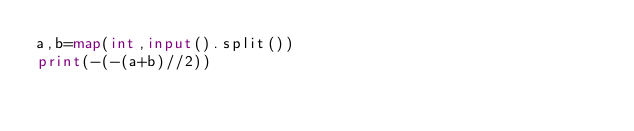Convert code to text. <code><loc_0><loc_0><loc_500><loc_500><_Python_>a,b=map(int,input().split())
print(-(-(a+b)//2))</code> 